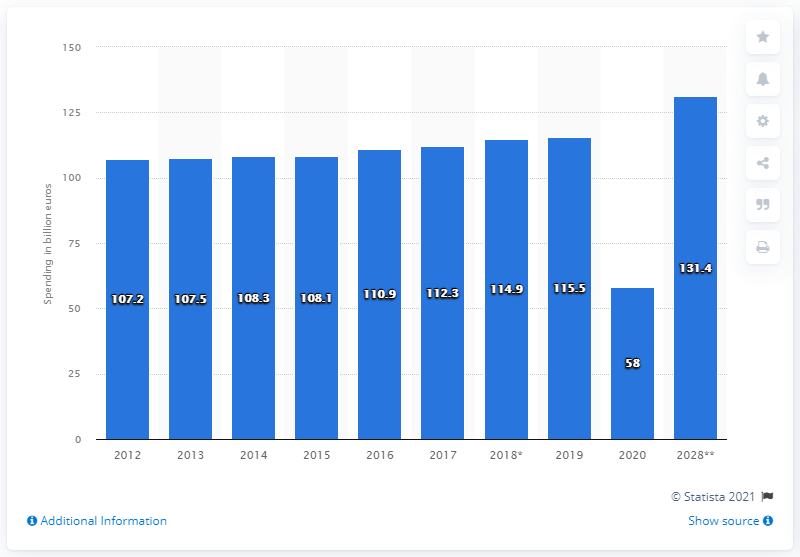Domestic tourism expenditure is expected to reach what in 2028? According to the bar chart, domestic tourism expenditure is forecasted to swell to an impressive 131.4 billion dollars by the year 2028, showcasing a significant growth trend over the years. 